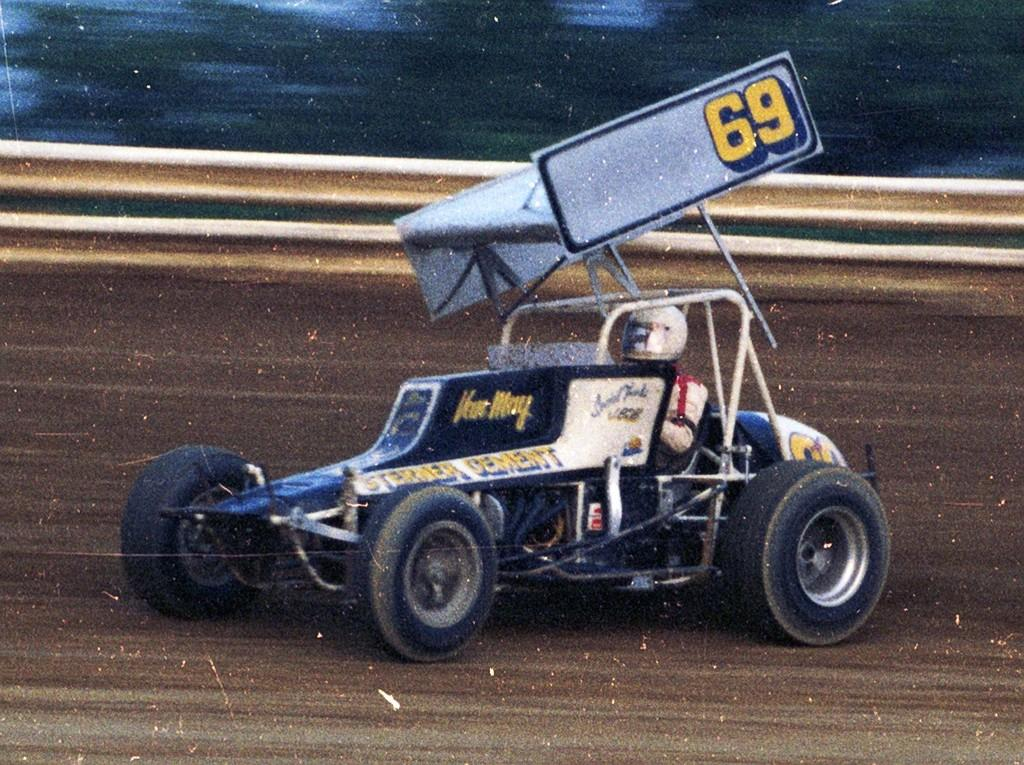<image>
Share a concise interpretation of the image provided. a blue and white go kart with the number 69 featured on its spoiler. 